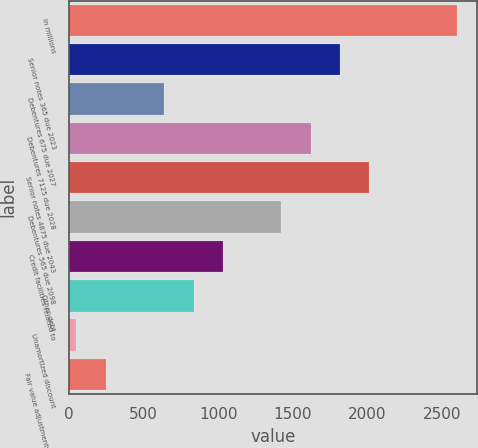<chart> <loc_0><loc_0><loc_500><loc_500><bar_chart><fcel>In millions<fcel>Senior notes 365 due 2023<fcel>Debentures 675 due 2027<fcel>Debentures 7125 due 2028<fcel>Senior notes 4875 due 2043<fcel>Debentures 565 due 2098<fcel>Credit facilities related to<fcel>Other debt<fcel>Unamortized discount<fcel>Fair value adjustments due to<nl><fcel>2602.5<fcel>1816.5<fcel>637.5<fcel>1620<fcel>2013<fcel>1423.5<fcel>1030.5<fcel>834<fcel>48<fcel>244.5<nl></chart> 